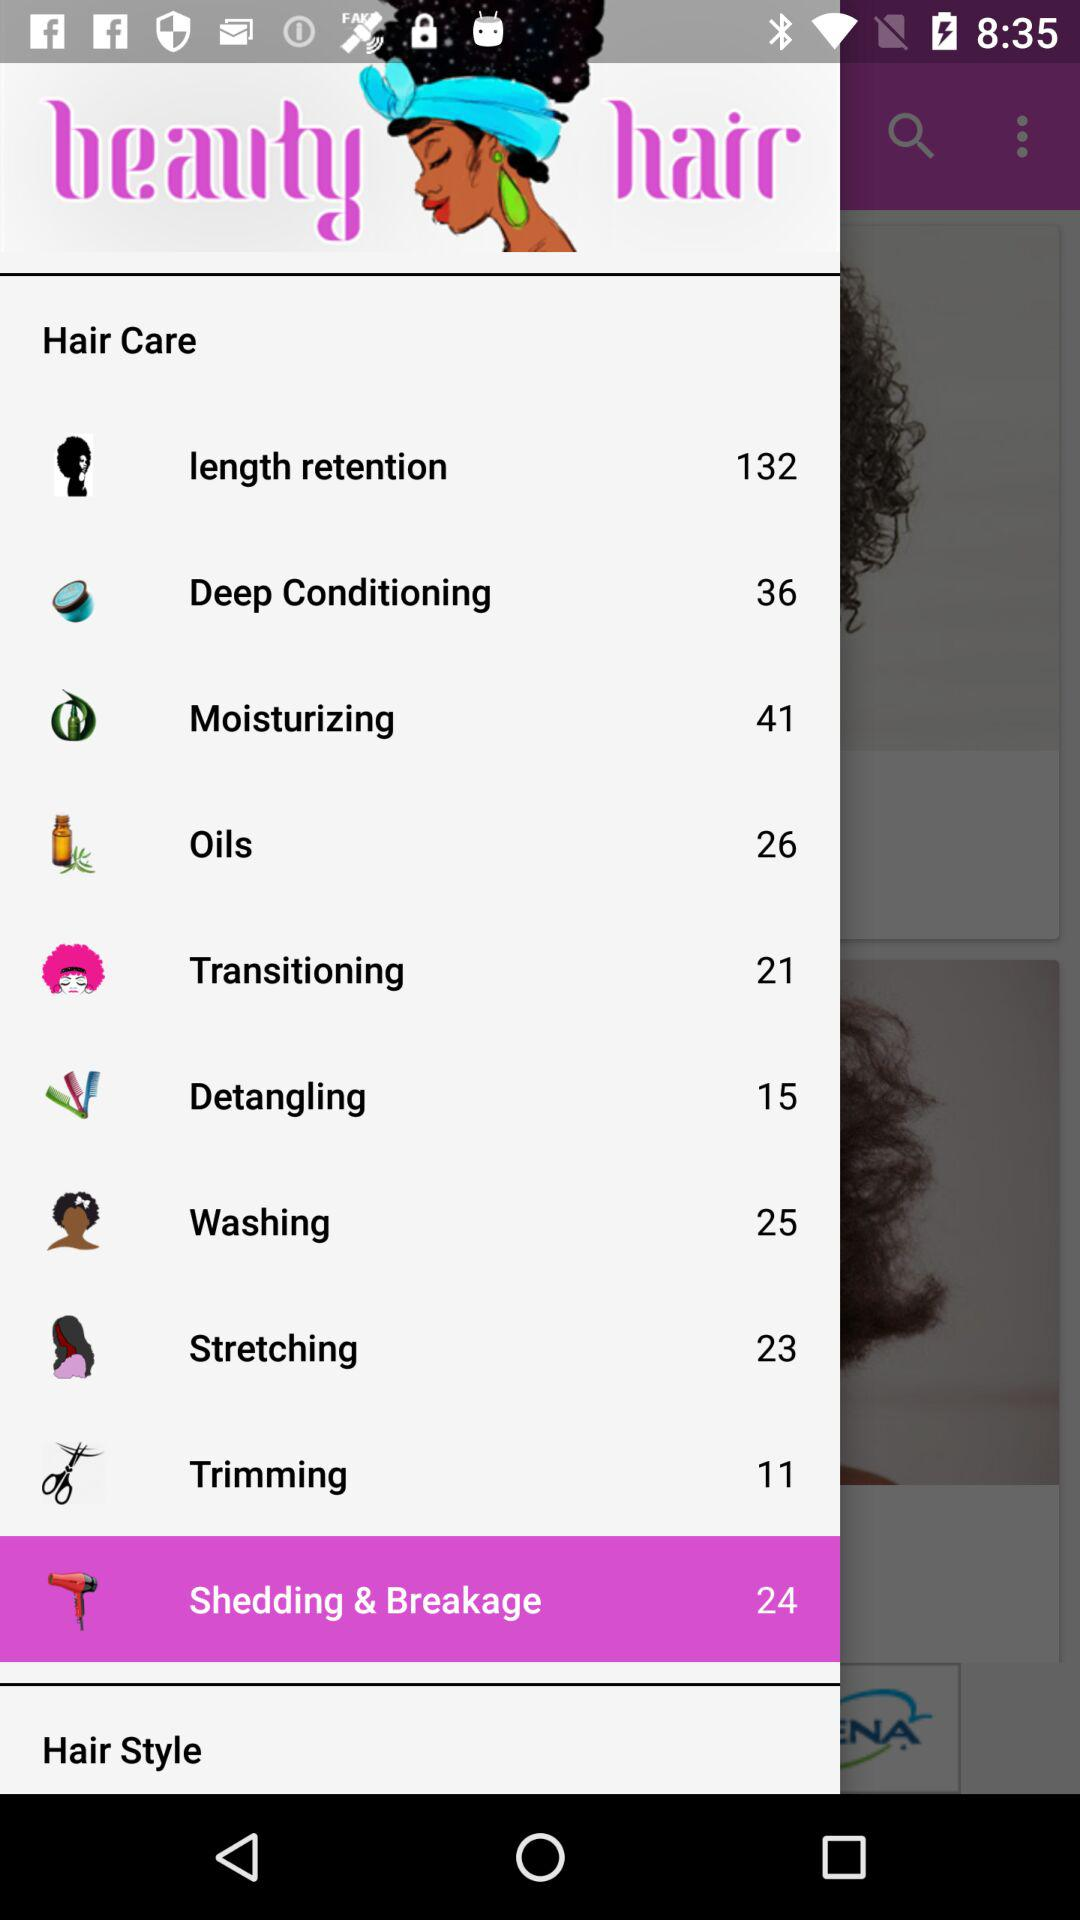What is the count of items in "Detangling"? The count of items is 15. 